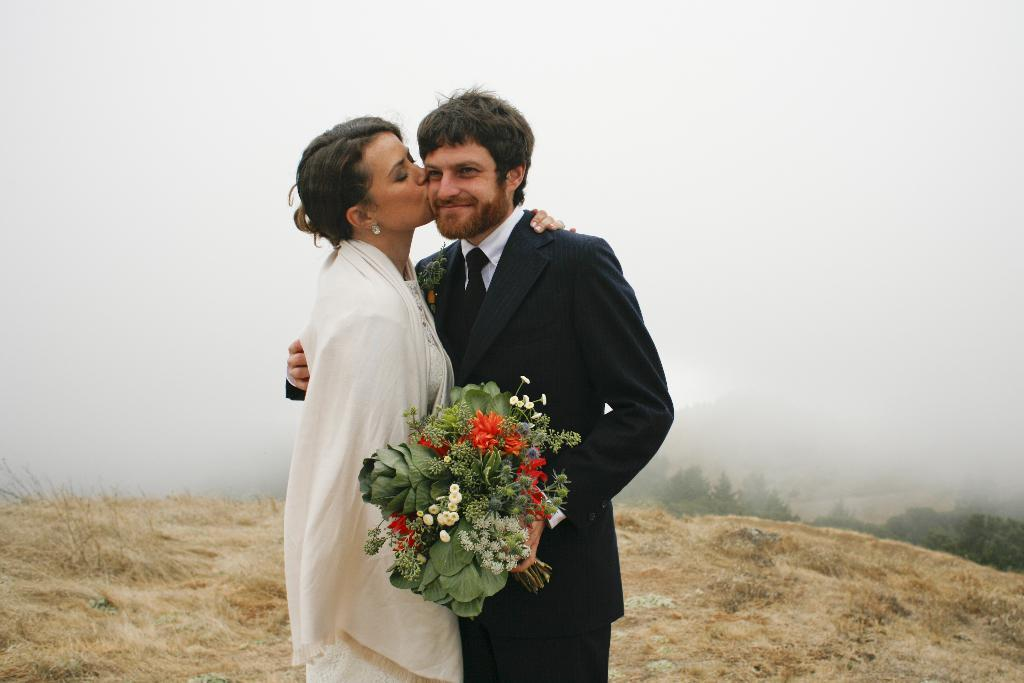How many people are in the image? There is a man and a woman in the image. What are the man and woman doing in the image? The man and woman are standing. What is the man holding in the image? The man is holding a flower bouquet. What can be seen in the background of the image? There are trees, grass, and fog in the background of the image. What type of twig is the man using to cause a roadblock in the image? There is no twig, roadblock, or road present in the image. 